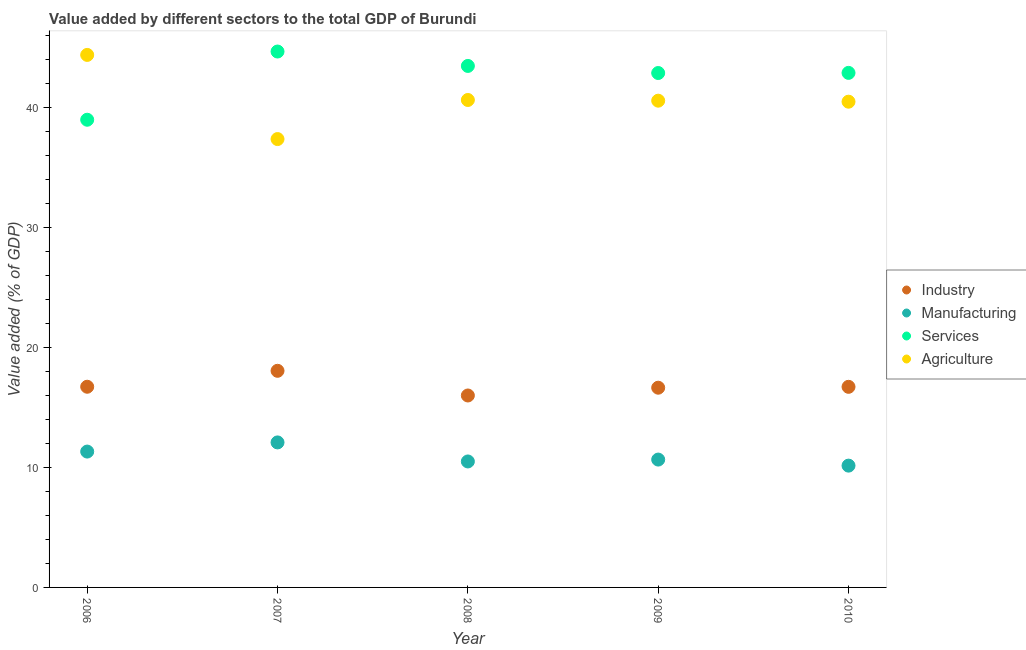What is the value added by manufacturing sector in 2009?
Ensure brevity in your answer.  10.65. Across all years, what is the maximum value added by industrial sector?
Make the answer very short. 18.04. Across all years, what is the minimum value added by manufacturing sector?
Give a very brief answer. 10.14. In which year was the value added by services sector maximum?
Your answer should be very brief. 2007. In which year was the value added by agricultural sector minimum?
Offer a terse response. 2007. What is the total value added by industrial sector in the graph?
Ensure brevity in your answer.  84.07. What is the difference between the value added by services sector in 2008 and that in 2009?
Provide a short and direct response. 0.59. What is the difference between the value added by manufacturing sector in 2006 and the value added by agricultural sector in 2009?
Give a very brief answer. -29.22. What is the average value added by services sector per year?
Ensure brevity in your answer.  42.54. In the year 2007, what is the difference between the value added by industrial sector and value added by agricultural sector?
Provide a succinct answer. -19.3. What is the ratio of the value added by agricultural sector in 2006 to that in 2008?
Provide a short and direct response. 1.09. Is the value added by manufacturing sector in 2008 less than that in 2009?
Provide a short and direct response. Yes. Is the difference between the value added by manufacturing sector in 2006 and 2008 greater than the difference between the value added by agricultural sector in 2006 and 2008?
Your response must be concise. No. What is the difference between the highest and the second highest value added by services sector?
Keep it short and to the point. 1.2. What is the difference between the highest and the lowest value added by services sector?
Give a very brief answer. 5.68. Is the sum of the value added by manufacturing sector in 2006 and 2010 greater than the maximum value added by industrial sector across all years?
Give a very brief answer. Yes. Is it the case that in every year, the sum of the value added by industrial sector and value added by manufacturing sector is greater than the value added by services sector?
Your answer should be very brief. No. How many dotlines are there?
Your response must be concise. 4. Are the values on the major ticks of Y-axis written in scientific E-notation?
Keep it short and to the point. No. Does the graph contain any zero values?
Make the answer very short. No. How are the legend labels stacked?
Make the answer very short. Vertical. What is the title of the graph?
Provide a succinct answer. Value added by different sectors to the total GDP of Burundi. What is the label or title of the X-axis?
Your answer should be very brief. Year. What is the label or title of the Y-axis?
Offer a terse response. Value added (% of GDP). What is the Value added (% of GDP) in Industry in 2006?
Provide a short and direct response. 16.71. What is the Value added (% of GDP) in Manufacturing in 2006?
Your answer should be compact. 11.31. What is the Value added (% of GDP) in Services in 2006?
Give a very brief answer. 38.95. What is the Value added (% of GDP) of Agriculture in 2006?
Your response must be concise. 44.34. What is the Value added (% of GDP) in Industry in 2007?
Offer a terse response. 18.04. What is the Value added (% of GDP) of Manufacturing in 2007?
Keep it short and to the point. 12.07. What is the Value added (% of GDP) of Services in 2007?
Provide a succinct answer. 44.63. What is the Value added (% of GDP) of Agriculture in 2007?
Your answer should be very brief. 37.34. What is the Value added (% of GDP) of Industry in 2008?
Offer a very short reply. 15.98. What is the Value added (% of GDP) of Manufacturing in 2008?
Keep it short and to the point. 10.49. What is the Value added (% of GDP) of Services in 2008?
Offer a terse response. 43.43. What is the Value added (% of GDP) in Agriculture in 2008?
Provide a short and direct response. 40.59. What is the Value added (% of GDP) of Industry in 2009?
Give a very brief answer. 16.63. What is the Value added (% of GDP) in Manufacturing in 2009?
Your answer should be compact. 10.65. What is the Value added (% of GDP) in Services in 2009?
Your response must be concise. 42.84. What is the Value added (% of GDP) of Agriculture in 2009?
Provide a short and direct response. 40.53. What is the Value added (% of GDP) in Industry in 2010?
Keep it short and to the point. 16.7. What is the Value added (% of GDP) of Manufacturing in 2010?
Offer a terse response. 10.14. What is the Value added (% of GDP) in Services in 2010?
Make the answer very short. 42.85. What is the Value added (% of GDP) in Agriculture in 2010?
Provide a short and direct response. 40.45. Across all years, what is the maximum Value added (% of GDP) of Industry?
Offer a terse response. 18.04. Across all years, what is the maximum Value added (% of GDP) in Manufacturing?
Provide a succinct answer. 12.07. Across all years, what is the maximum Value added (% of GDP) of Services?
Your answer should be very brief. 44.63. Across all years, what is the maximum Value added (% of GDP) in Agriculture?
Ensure brevity in your answer.  44.34. Across all years, what is the minimum Value added (% of GDP) in Industry?
Offer a terse response. 15.98. Across all years, what is the minimum Value added (% of GDP) of Manufacturing?
Provide a succinct answer. 10.14. Across all years, what is the minimum Value added (% of GDP) in Services?
Provide a succinct answer. 38.95. Across all years, what is the minimum Value added (% of GDP) in Agriculture?
Your answer should be very brief. 37.34. What is the total Value added (% of GDP) of Industry in the graph?
Your response must be concise. 84.07. What is the total Value added (% of GDP) of Manufacturing in the graph?
Provide a succinct answer. 54.67. What is the total Value added (% of GDP) in Services in the graph?
Your answer should be compact. 212.68. What is the total Value added (% of GDP) in Agriculture in the graph?
Your response must be concise. 203.25. What is the difference between the Value added (% of GDP) in Industry in 2006 and that in 2007?
Provide a succinct answer. -1.33. What is the difference between the Value added (% of GDP) of Manufacturing in 2006 and that in 2007?
Provide a short and direct response. -0.76. What is the difference between the Value added (% of GDP) of Services in 2006 and that in 2007?
Your answer should be very brief. -5.68. What is the difference between the Value added (% of GDP) of Agriculture in 2006 and that in 2007?
Provide a succinct answer. 7.01. What is the difference between the Value added (% of GDP) in Industry in 2006 and that in 2008?
Provide a succinct answer. 0.73. What is the difference between the Value added (% of GDP) of Manufacturing in 2006 and that in 2008?
Keep it short and to the point. 0.82. What is the difference between the Value added (% of GDP) of Services in 2006 and that in 2008?
Make the answer very short. -4.48. What is the difference between the Value added (% of GDP) in Agriculture in 2006 and that in 2008?
Keep it short and to the point. 3.75. What is the difference between the Value added (% of GDP) of Industry in 2006 and that in 2009?
Provide a succinct answer. 0.08. What is the difference between the Value added (% of GDP) in Manufacturing in 2006 and that in 2009?
Offer a terse response. 0.67. What is the difference between the Value added (% of GDP) of Services in 2006 and that in 2009?
Offer a terse response. -3.89. What is the difference between the Value added (% of GDP) of Agriculture in 2006 and that in 2009?
Give a very brief answer. 3.81. What is the difference between the Value added (% of GDP) in Industry in 2006 and that in 2010?
Your answer should be very brief. 0.01. What is the difference between the Value added (% of GDP) of Manufacturing in 2006 and that in 2010?
Keep it short and to the point. 1.17. What is the difference between the Value added (% of GDP) of Services in 2006 and that in 2010?
Offer a very short reply. -3.9. What is the difference between the Value added (% of GDP) of Agriculture in 2006 and that in 2010?
Your response must be concise. 3.9. What is the difference between the Value added (% of GDP) in Industry in 2007 and that in 2008?
Offer a very short reply. 2.06. What is the difference between the Value added (% of GDP) of Manufacturing in 2007 and that in 2008?
Your answer should be very brief. 1.58. What is the difference between the Value added (% of GDP) of Services in 2007 and that in 2008?
Make the answer very short. 1.2. What is the difference between the Value added (% of GDP) of Agriculture in 2007 and that in 2008?
Your response must be concise. -3.25. What is the difference between the Value added (% of GDP) of Industry in 2007 and that in 2009?
Your answer should be very brief. 1.41. What is the difference between the Value added (% of GDP) of Manufacturing in 2007 and that in 2009?
Provide a succinct answer. 1.43. What is the difference between the Value added (% of GDP) in Services in 2007 and that in 2009?
Provide a short and direct response. 1.79. What is the difference between the Value added (% of GDP) in Agriculture in 2007 and that in 2009?
Your response must be concise. -3.2. What is the difference between the Value added (% of GDP) in Industry in 2007 and that in 2010?
Give a very brief answer. 1.33. What is the difference between the Value added (% of GDP) of Manufacturing in 2007 and that in 2010?
Provide a succinct answer. 1.93. What is the difference between the Value added (% of GDP) in Services in 2007 and that in 2010?
Keep it short and to the point. 1.78. What is the difference between the Value added (% of GDP) of Agriculture in 2007 and that in 2010?
Make the answer very short. -3.11. What is the difference between the Value added (% of GDP) in Industry in 2008 and that in 2009?
Keep it short and to the point. -0.65. What is the difference between the Value added (% of GDP) of Manufacturing in 2008 and that in 2009?
Give a very brief answer. -0.16. What is the difference between the Value added (% of GDP) in Services in 2008 and that in 2009?
Make the answer very short. 0.59. What is the difference between the Value added (% of GDP) in Agriculture in 2008 and that in 2009?
Provide a short and direct response. 0.06. What is the difference between the Value added (% of GDP) of Industry in 2008 and that in 2010?
Your answer should be compact. -0.72. What is the difference between the Value added (% of GDP) in Manufacturing in 2008 and that in 2010?
Give a very brief answer. 0.35. What is the difference between the Value added (% of GDP) in Services in 2008 and that in 2010?
Keep it short and to the point. 0.58. What is the difference between the Value added (% of GDP) in Agriculture in 2008 and that in 2010?
Provide a short and direct response. 0.14. What is the difference between the Value added (% of GDP) of Industry in 2009 and that in 2010?
Make the answer very short. -0.07. What is the difference between the Value added (% of GDP) in Manufacturing in 2009 and that in 2010?
Give a very brief answer. 0.5. What is the difference between the Value added (% of GDP) in Services in 2009 and that in 2010?
Ensure brevity in your answer.  -0.01. What is the difference between the Value added (% of GDP) in Agriculture in 2009 and that in 2010?
Make the answer very short. 0.08. What is the difference between the Value added (% of GDP) of Industry in 2006 and the Value added (% of GDP) of Manufacturing in 2007?
Your answer should be very brief. 4.64. What is the difference between the Value added (% of GDP) in Industry in 2006 and the Value added (% of GDP) in Services in 2007?
Provide a short and direct response. -27.91. What is the difference between the Value added (% of GDP) in Industry in 2006 and the Value added (% of GDP) in Agriculture in 2007?
Your answer should be compact. -20.62. What is the difference between the Value added (% of GDP) in Manufacturing in 2006 and the Value added (% of GDP) in Services in 2007?
Ensure brevity in your answer.  -33.31. What is the difference between the Value added (% of GDP) of Manufacturing in 2006 and the Value added (% of GDP) of Agriculture in 2007?
Give a very brief answer. -26.02. What is the difference between the Value added (% of GDP) in Services in 2006 and the Value added (% of GDP) in Agriculture in 2007?
Your answer should be very brief. 1.61. What is the difference between the Value added (% of GDP) in Industry in 2006 and the Value added (% of GDP) in Manufacturing in 2008?
Your answer should be very brief. 6.22. What is the difference between the Value added (% of GDP) of Industry in 2006 and the Value added (% of GDP) of Services in 2008?
Ensure brevity in your answer.  -26.71. What is the difference between the Value added (% of GDP) in Industry in 2006 and the Value added (% of GDP) in Agriculture in 2008?
Give a very brief answer. -23.88. What is the difference between the Value added (% of GDP) in Manufacturing in 2006 and the Value added (% of GDP) in Services in 2008?
Your answer should be very brief. -32.11. What is the difference between the Value added (% of GDP) of Manufacturing in 2006 and the Value added (% of GDP) of Agriculture in 2008?
Give a very brief answer. -29.28. What is the difference between the Value added (% of GDP) of Services in 2006 and the Value added (% of GDP) of Agriculture in 2008?
Your answer should be very brief. -1.65. What is the difference between the Value added (% of GDP) of Industry in 2006 and the Value added (% of GDP) of Manufacturing in 2009?
Your answer should be compact. 6.06. What is the difference between the Value added (% of GDP) in Industry in 2006 and the Value added (% of GDP) in Services in 2009?
Make the answer very short. -26.13. What is the difference between the Value added (% of GDP) of Industry in 2006 and the Value added (% of GDP) of Agriculture in 2009?
Offer a terse response. -23.82. What is the difference between the Value added (% of GDP) in Manufacturing in 2006 and the Value added (% of GDP) in Services in 2009?
Provide a succinct answer. -31.52. What is the difference between the Value added (% of GDP) of Manufacturing in 2006 and the Value added (% of GDP) of Agriculture in 2009?
Your answer should be very brief. -29.22. What is the difference between the Value added (% of GDP) in Services in 2006 and the Value added (% of GDP) in Agriculture in 2009?
Your answer should be compact. -1.59. What is the difference between the Value added (% of GDP) in Industry in 2006 and the Value added (% of GDP) in Manufacturing in 2010?
Offer a terse response. 6.57. What is the difference between the Value added (% of GDP) in Industry in 2006 and the Value added (% of GDP) in Services in 2010?
Keep it short and to the point. -26.14. What is the difference between the Value added (% of GDP) in Industry in 2006 and the Value added (% of GDP) in Agriculture in 2010?
Make the answer very short. -23.74. What is the difference between the Value added (% of GDP) in Manufacturing in 2006 and the Value added (% of GDP) in Services in 2010?
Your answer should be compact. -31.53. What is the difference between the Value added (% of GDP) of Manufacturing in 2006 and the Value added (% of GDP) of Agriculture in 2010?
Your response must be concise. -29.14. What is the difference between the Value added (% of GDP) in Services in 2006 and the Value added (% of GDP) in Agriculture in 2010?
Provide a succinct answer. -1.5. What is the difference between the Value added (% of GDP) of Industry in 2007 and the Value added (% of GDP) of Manufacturing in 2008?
Give a very brief answer. 7.55. What is the difference between the Value added (% of GDP) in Industry in 2007 and the Value added (% of GDP) in Services in 2008?
Make the answer very short. -25.39. What is the difference between the Value added (% of GDP) in Industry in 2007 and the Value added (% of GDP) in Agriculture in 2008?
Your response must be concise. -22.55. What is the difference between the Value added (% of GDP) in Manufacturing in 2007 and the Value added (% of GDP) in Services in 2008?
Your answer should be very brief. -31.35. What is the difference between the Value added (% of GDP) of Manufacturing in 2007 and the Value added (% of GDP) of Agriculture in 2008?
Offer a terse response. -28.52. What is the difference between the Value added (% of GDP) in Services in 2007 and the Value added (% of GDP) in Agriculture in 2008?
Give a very brief answer. 4.03. What is the difference between the Value added (% of GDP) of Industry in 2007 and the Value added (% of GDP) of Manufacturing in 2009?
Keep it short and to the point. 7.39. What is the difference between the Value added (% of GDP) in Industry in 2007 and the Value added (% of GDP) in Services in 2009?
Your response must be concise. -24.8. What is the difference between the Value added (% of GDP) of Industry in 2007 and the Value added (% of GDP) of Agriculture in 2009?
Give a very brief answer. -22.49. What is the difference between the Value added (% of GDP) of Manufacturing in 2007 and the Value added (% of GDP) of Services in 2009?
Provide a short and direct response. -30.76. What is the difference between the Value added (% of GDP) of Manufacturing in 2007 and the Value added (% of GDP) of Agriculture in 2009?
Offer a very short reply. -28.46. What is the difference between the Value added (% of GDP) in Services in 2007 and the Value added (% of GDP) in Agriculture in 2009?
Offer a terse response. 4.09. What is the difference between the Value added (% of GDP) in Industry in 2007 and the Value added (% of GDP) in Manufacturing in 2010?
Offer a terse response. 7.9. What is the difference between the Value added (% of GDP) of Industry in 2007 and the Value added (% of GDP) of Services in 2010?
Offer a terse response. -24.81. What is the difference between the Value added (% of GDP) of Industry in 2007 and the Value added (% of GDP) of Agriculture in 2010?
Offer a very short reply. -22.41. What is the difference between the Value added (% of GDP) in Manufacturing in 2007 and the Value added (% of GDP) in Services in 2010?
Ensure brevity in your answer.  -30.77. What is the difference between the Value added (% of GDP) of Manufacturing in 2007 and the Value added (% of GDP) of Agriculture in 2010?
Provide a succinct answer. -28.37. What is the difference between the Value added (% of GDP) in Services in 2007 and the Value added (% of GDP) in Agriculture in 2010?
Offer a terse response. 4.18. What is the difference between the Value added (% of GDP) in Industry in 2008 and the Value added (% of GDP) in Manufacturing in 2009?
Keep it short and to the point. 5.34. What is the difference between the Value added (% of GDP) in Industry in 2008 and the Value added (% of GDP) in Services in 2009?
Keep it short and to the point. -26.85. What is the difference between the Value added (% of GDP) of Industry in 2008 and the Value added (% of GDP) of Agriculture in 2009?
Make the answer very short. -24.55. What is the difference between the Value added (% of GDP) of Manufacturing in 2008 and the Value added (% of GDP) of Services in 2009?
Give a very brief answer. -32.35. What is the difference between the Value added (% of GDP) in Manufacturing in 2008 and the Value added (% of GDP) in Agriculture in 2009?
Make the answer very short. -30.04. What is the difference between the Value added (% of GDP) of Services in 2008 and the Value added (% of GDP) of Agriculture in 2009?
Ensure brevity in your answer.  2.89. What is the difference between the Value added (% of GDP) in Industry in 2008 and the Value added (% of GDP) in Manufacturing in 2010?
Keep it short and to the point. 5.84. What is the difference between the Value added (% of GDP) of Industry in 2008 and the Value added (% of GDP) of Services in 2010?
Offer a very short reply. -26.86. What is the difference between the Value added (% of GDP) in Industry in 2008 and the Value added (% of GDP) in Agriculture in 2010?
Provide a succinct answer. -24.47. What is the difference between the Value added (% of GDP) in Manufacturing in 2008 and the Value added (% of GDP) in Services in 2010?
Provide a succinct answer. -32.36. What is the difference between the Value added (% of GDP) of Manufacturing in 2008 and the Value added (% of GDP) of Agriculture in 2010?
Offer a terse response. -29.96. What is the difference between the Value added (% of GDP) in Services in 2008 and the Value added (% of GDP) in Agriculture in 2010?
Give a very brief answer. 2.98. What is the difference between the Value added (% of GDP) of Industry in 2009 and the Value added (% of GDP) of Manufacturing in 2010?
Give a very brief answer. 6.49. What is the difference between the Value added (% of GDP) in Industry in 2009 and the Value added (% of GDP) in Services in 2010?
Give a very brief answer. -26.22. What is the difference between the Value added (% of GDP) of Industry in 2009 and the Value added (% of GDP) of Agriculture in 2010?
Make the answer very short. -23.82. What is the difference between the Value added (% of GDP) in Manufacturing in 2009 and the Value added (% of GDP) in Services in 2010?
Your answer should be compact. -32.2. What is the difference between the Value added (% of GDP) in Manufacturing in 2009 and the Value added (% of GDP) in Agriculture in 2010?
Ensure brevity in your answer.  -29.8. What is the difference between the Value added (% of GDP) in Services in 2009 and the Value added (% of GDP) in Agriculture in 2010?
Offer a terse response. 2.39. What is the average Value added (% of GDP) of Industry per year?
Keep it short and to the point. 16.81. What is the average Value added (% of GDP) in Manufacturing per year?
Your response must be concise. 10.93. What is the average Value added (% of GDP) of Services per year?
Give a very brief answer. 42.54. What is the average Value added (% of GDP) in Agriculture per year?
Provide a short and direct response. 40.65. In the year 2006, what is the difference between the Value added (% of GDP) in Industry and Value added (% of GDP) in Manufacturing?
Give a very brief answer. 5.4. In the year 2006, what is the difference between the Value added (% of GDP) in Industry and Value added (% of GDP) in Services?
Your response must be concise. -22.23. In the year 2006, what is the difference between the Value added (% of GDP) in Industry and Value added (% of GDP) in Agriculture?
Offer a terse response. -27.63. In the year 2006, what is the difference between the Value added (% of GDP) in Manufacturing and Value added (% of GDP) in Services?
Your answer should be compact. -27.63. In the year 2006, what is the difference between the Value added (% of GDP) of Manufacturing and Value added (% of GDP) of Agriculture?
Provide a succinct answer. -33.03. In the year 2006, what is the difference between the Value added (% of GDP) in Services and Value added (% of GDP) in Agriculture?
Ensure brevity in your answer.  -5.4. In the year 2007, what is the difference between the Value added (% of GDP) in Industry and Value added (% of GDP) in Manufacturing?
Your response must be concise. 5.96. In the year 2007, what is the difference between the Value added (% of GDP) of Industry and Value added (% of GDP) of Services?
Provide a succinct answer. -26.59. In the year 2007, what is the difference between the Value added (% of GDP) in Industry and Value added (% of GDP) in Agriculture?
Your answer should be very brief. -19.3. In the year 2007, what is the difference between the Value added (% of GDP) in Manufacturing and Value added (% of GDP) in Services?
Give a very brief answer. -32.55. In the year 2007, what is the difference between the Value added (% of GDP) of Manufacturing and Value added (% of GDP) of Agriculture?
Ensure brevity in your answer.  -25.26. In the year 2007, what is the difference between the Value added (% of GDP) in Services and Value added (% of GDP) in Agriculture?
Provide a short and direct response. 7.29. In the year 2008, what is the difference between the Value added (% of GDP) of Industry and Value added (% of GDP) of Manufacturing?
Provide a succinct answer. 5.49. In the year 2008, what is the difference between the Value added (% of GDP) of Industry and Value added (% of GDP) of Services?
Your answer should be very brief. -27.44. In the year 2008, what is the difference between the Value added (% of GDP) in Industry and Value added (% of GDP) in Agriculture?
Keep it short and to the point. -24.61. In the year 2008, what is the difference between the Value added (% of GDP) in Manufacturing and Value added (% of GDP) in Services?
Your response must be concise. -32.94. In the year 2008, what is the difference between the Value added (% of GDP) of Manufacturing and Value added (% of GDP) of Agriculture?
Give a very brief answer. -30.1. In the year 2008, what is the difference between the Value added (% of GDP) in Services and Value added (% of GDP) in Agriculture?
Your answer should be very brief. 2.83. In the year 2009, what is the difference between the Value added (% of GDP) of Industry and Value added (% of GDP) of Manufacturing?
Your response must be concise. 5.98. In the year 2009, what is the difference between the Value added (% of GDP) of Industry and Value added (% of GDP) of Services?
Keep it short and to the point. -26.2. In the year 2009, what is the difference between the Value added (% of GDP) in Industry and Value added (% of GDP) in Agriculture?
Give a very brief answer. -23.9. In the year 2009, what is the difference between the Value added (% of GDP) in Manufacturing and Value added (% of GDP) in Services?
Offer a very short reply. -32.19. In the year 2009, what is the difference between the Value added (% of GDP) of Manufacturing and Value added (% of GDP) of Agriculture?
Offer a terse response. -29.89. In the year 2009, what is the difference between the Value added (% of GDP) of Services and Value added (% of GDP) of Agriculture?
Offer a very short reply. 2.3. In the year 2010, what is the difference between the Value added (% of GDP) of Industry and Value added (% of GDP) of Manufacturing?
Offer a very short reply. 6.56. In the year 2010, what is the difference between the Value added (% of GDP) of Industry and Value added (% of GDP) of Services?
Ensure brevity in your answer.  -26.14. In the year 2010, what is the difference between the Value added (% of GDP) of Industry and Value added (% of GDP) of Agriculture?
Make the answer very short. -23.74. In the year 2010, what is the difference between the Value added (% of GDP) in Manufacturing and Value added (% of GDP) in Services?
Make the answer very short. -32.7. In the year 2010, what is the difference between the Value added (% of GDP) in Manufacturing and Value added (% of GDP) in Agriculture?
Keep it short and to the point. -30.31. In the year 2010, what is the difference between the Value added (% of GDP) of Services and Value added (% of GDP) of Agriculture?
Give a very brief answer. 2.4. What is the ratio of the Value added (% of GDP) in Industry in 2006 to that in 2007?
Make the answer very short. 0.93. What is the ratio of the Value added (% of GDP) in Manufacturing in 2006 to that in 2007?
Offer a terse response. 0.94. What is the ratio of the Value added (% of GDP) in Services in 2006 to that in 2007?
Provide a succinct answer. 0.87. What is the ratio of the Value added (% of GDP) of Agriculture in 2006 to that in 2007?
Provide a succinct answer. 1.19. What is the ratio of the Value added (% of GDP) of Industry in 2006 to that in 2008?
Offer a very short reply. 1.05. What is the ratio of the Value added (% of GDP) in Manufacturing in 2006 to that in 2008?
Your answer should be very brief. 1.08. What is the ratio of the Value added (% of GDP) of Services in 2006 to that in 2008?
Offer a terse response. 0.9. What is the ratio of the Value added (% of GDP) of Agriculture in 2006 to that in 2008?
Offer a very short reply. 1.09. What is the ratio of the Value added (% of GDP) in Industry in 2006 to that in 2009?
Keep it short and to the point. 1. What is the ratio of the Value added (% of GDP) of Manufacturing in 2006 to that in 2009?
Provide a short and direct response. 1.06. What is the ratio of the Value added (% of GDP) of Services in 2006 to that in 2009?
Your answer should be very brief. 0.91. What is the ratio of the Value added (% of GDP) in Agriculture in 2006 to that in 2009?
Provide a short and direct response. 1.09. What is the ratio of the Value added (% of GDP) in Industry in 2006 to that in 2010?
Your answer should be very brief. 1. What is the ratio of the Value added (% of GDP) of Manufacturing in 2006 to that in 2010?
Offer a terse response. 1.12. What is the ratio of the Value added (% of GDP) of Services in 2006 to that in 2010?
Offer a terse response. 0.91. What is the ratio of the Value added (% of GDP) of Agriculture in 2006 to that in 2010?
Make the answer very short. 1.1. What is the ratio of the Value added (% of GDP) in Industry in 2007 to that in 2008?
Your answer should be compact. 1.13. What is the ratio of the Value added (% of GDP) in Manufacturing in 2007 to that in 2008?
Make the answer very short. 1.15. What is the ratio of the Value added (% of GDP) of Services in 2007 to that in 2008?
Provide a succinct answer. 1.03. What is the ratio of the Value added (% of GDP) of Agriculture in 2007 to that in 2008?
Provide a succinct answer. 0.92. What is the ratio of the Value added (% of GDP) in Industry in 2007 to that in 2009?
Keep it short and to the point. 1.08. What is the ratio of the Value added (% of GDP) of Manufacturing in 2007 to that in 2009?
Your answer should be compact. 1.13. What is the ratio of the Value added (% of GDP) of Services in 2007 to that in 2009?
Keep it short and to the point. 1.04. What is the ratio of the Value added (% of GDP) in Agriculture in 2007 to that in 2009?
Keep it short and to the point. 0.92. What is the ratio of the Value added (% of GDP) of Industry in 2007 to that in 2010?
Provide a succinct answer. 1.08. What is the ratio of the Value added (% of GDP) in Manufacturing in 2007 to that in 2010?
Your response must be concise. 1.19. What is the ratio of the Value added (% of GDP) of Services in 2007 to that in 2010?
Offer a terse response. 1.04. What is the ratio of the Value added (% of GDP) in Industry in 2008 to that in 2009?
Provide a succinct answer. 0.96. What is the ratio of the Value added (% of GDP) in Manufacturing in 2008 to that in 2009?
Make the answer very short. 0.99. What is the ratio of the Value added (% of GDP) of Services in 2008 to that in 2009?
Make the answer very short. 1.01. What is the ratio of the Value added (% of GDP) in Agriculture in 2008 to that in 2009?
Give a very brief answer. 1. What is the ratio of the Value added (% of GDP) of Industry in 2008 to that in 2010?
Your response must be concise. 0.96. What is the ratio of the Value added (% of GDP) in Manufacturing in 2008 to that in 2010?
Make the answer very short. 1.03. What is the ratio of the Value added (% of GDP) of Services in 2008 to that in 2010?
Give a very brief answer. 1.01. What is the ratio of the Value added (% of GDP) of Manufacturing in 2009 to that in 2010?
Give a very brief answer. 1.05. What is the ratio of the Value added (% of GDP) of Agriculture in 2009 to that in 2010?
Make the answer very short. 1. What is the difference between the highest and the second highest Value added (% of GDP) of Industry?
Make the answer very short. 1.33. What is the difference between the highest and the second highest Value added (% of GDP) in Manufacturing?
Your response must be concise. 0.76. What is the difference between the highest and the second highest Value added (% of GDP) of Services?
Your response must be concise. 1.2. What is the difference between the highest and the second highest Value added (% of GDP) of Agriculture?
Give a very brief answer. 3.75. What is the difference between the highest and the lowest Value added (% of GDP) of Industry?
Offer a terse response. 2.06. What is the difference between the highest and the lowest Value added (% of GDP) of Manufacturing?
Your answer should be very brief. 1.93. What is the difference between the highest and the lowest Value added (% of GDP) of Services?
Your answer should be very brief. 5.68. What is the difference between the highest and the lowest Value added (% of GDP) in Agriculture?
Your answer should be compact. 7.01. 